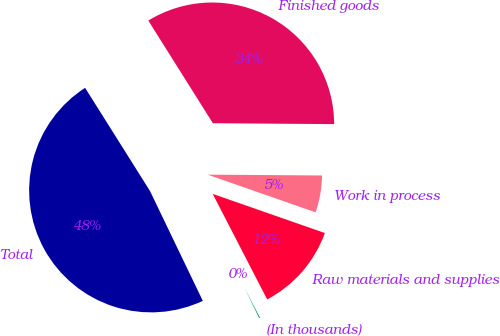<chart> <loc_0><loc_0><loc_500><loc_500><pie_chart><fcel>(In thousands)<fcel>Raw materials and supplies<fcel>Work in process<fcel>Finished goods<fcel>Total<nl><fcel>0.45%<fcel>12.07%<fcel>5.23%<fcel>34.05%<fcel>48.19%<nl></chart> 